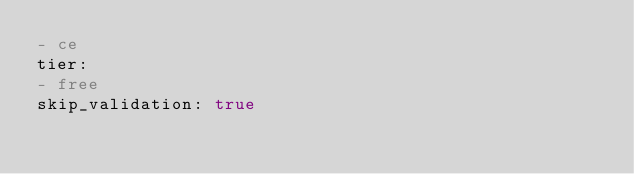Convert code to text. <code><loc_0><loc_0><loc_500><loc_500><_YAML_>- ce
tier:
- free
skip_validation: true
</code> 